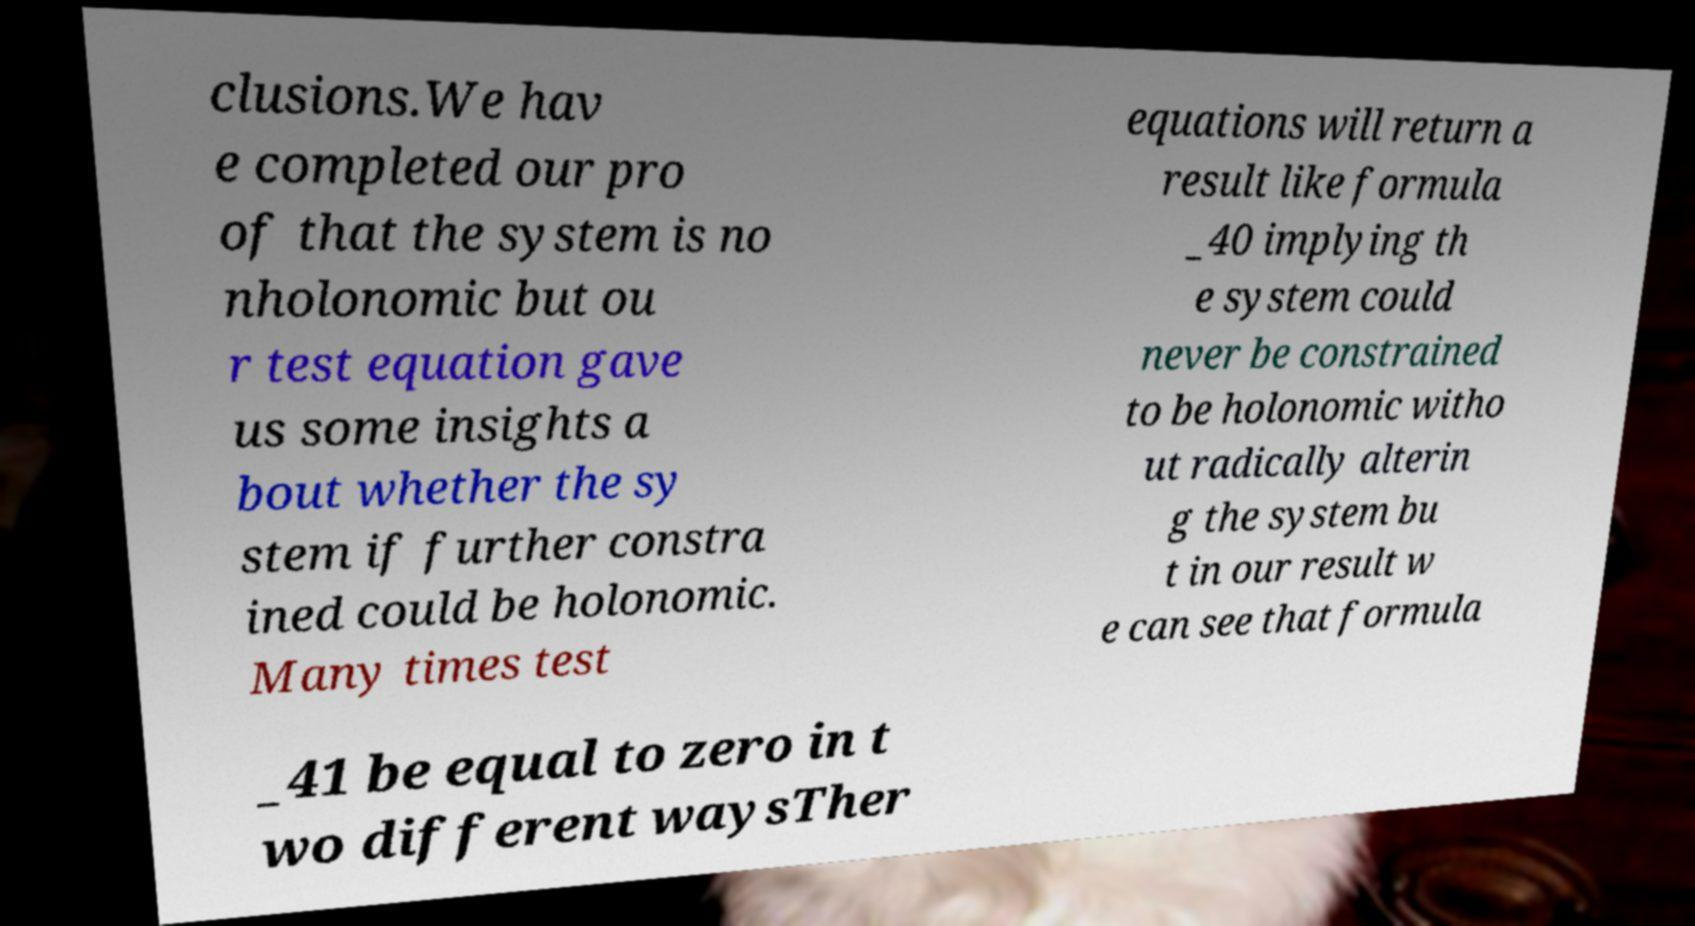Can you read and provide the text displayed in the image?This photo seems to have some interesting text. Can you extract and type it out for me? clusions.We hav e completed our pro of that the system is no nholonomic but ou r test equation gave us some insights a bout whether the sy stem if further constra ined could be holonomic. Many times test equations will return a result like formula _40 implying th e system could never be constrained to be holonomic witho ut radically alterin g the system bu t in our result w e can see that formula _41 be equal to zero in t wo different waysTher 